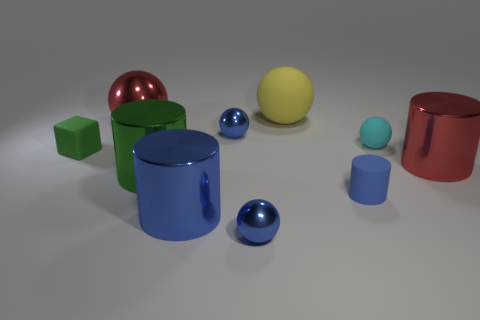There is a tiny metallic object that is in front of the big green shiny object; what color is it? blue 